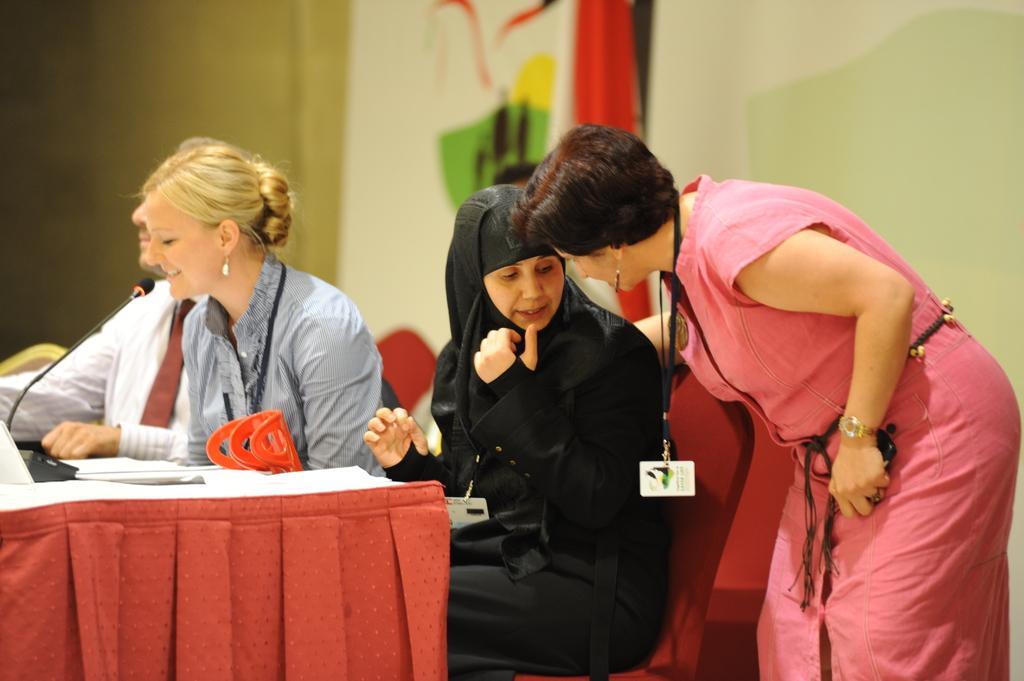Please provide a concise description of this image. In this image i can see few people sitting in chairs in front of a table and a woman standing. In the background i can see a cloth and a wall. 